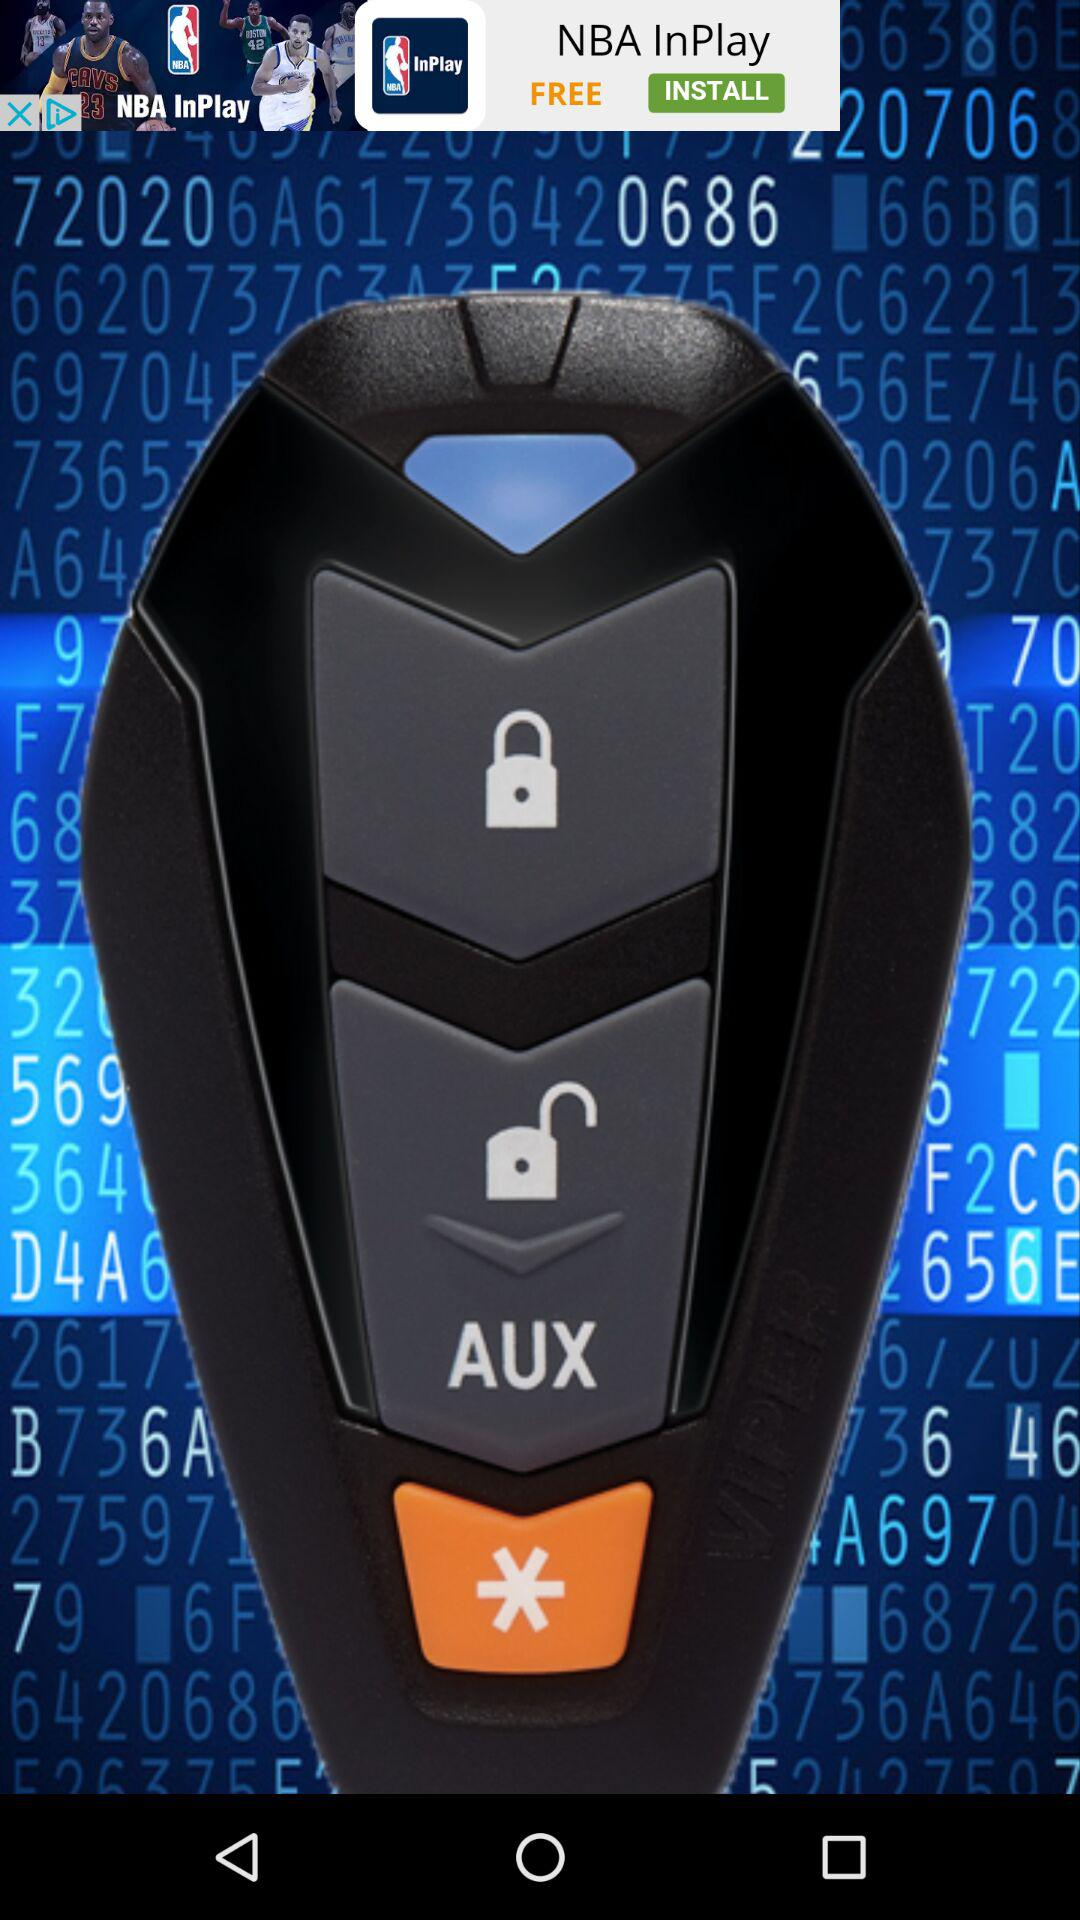How many padlocks are on the remote control?
Answer the question using a single word or phrase. 2 